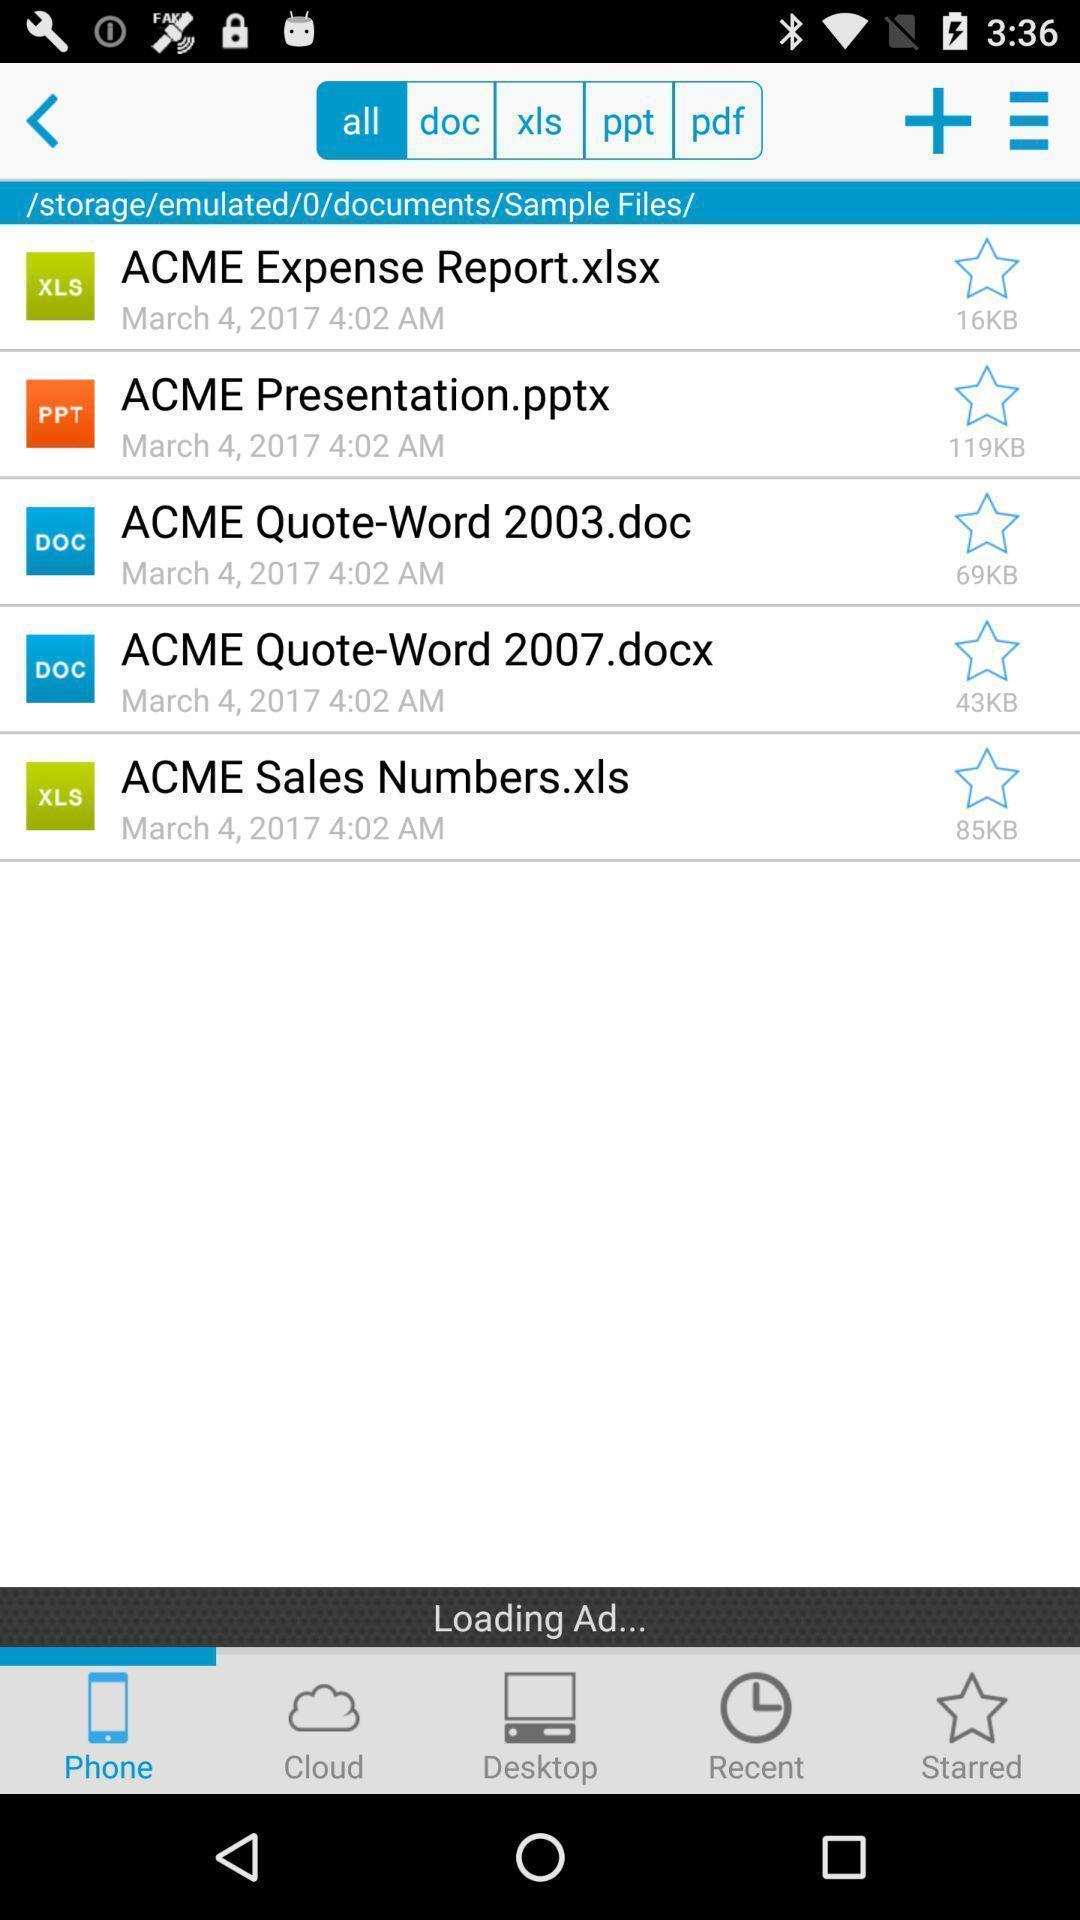What can you discern from this picture? Window displaying all types of documents. 